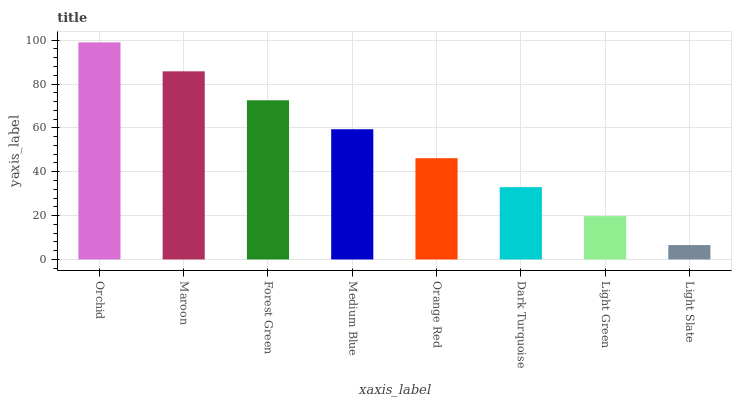Is Light Slate the minimum?
Answer yes or no. Yes. Is Orchid the maximum?
Answer yes or no. Yes. Is Maroon the minimum?
Answer yes or no. No. Is Maroon the maximum?
Answer yes or no. No. Is Orchid greater than Maroon?
Answer yes or no. Yes. Is Maroon less than Orchid?
Answer yes or no. Yes. Is Maroon greater than Orchid?
Answer yes or no. No. Is Orchid less than Maroon?
Answer yes or no. No. Is Medium Blue the high median?
Answer yes or no. Yes. Is Orange Red the low median?
Answer yes or no. Yes. Is Light Slate the high median?
Answer yes or no. No. Is Light Slate the low median?
Answer yes or no. No. 